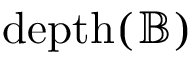<formula> <loc_0><loc_0><loc_500><loc_500>{ d e p t h } ( { \mathbb { B } } )</formula> 